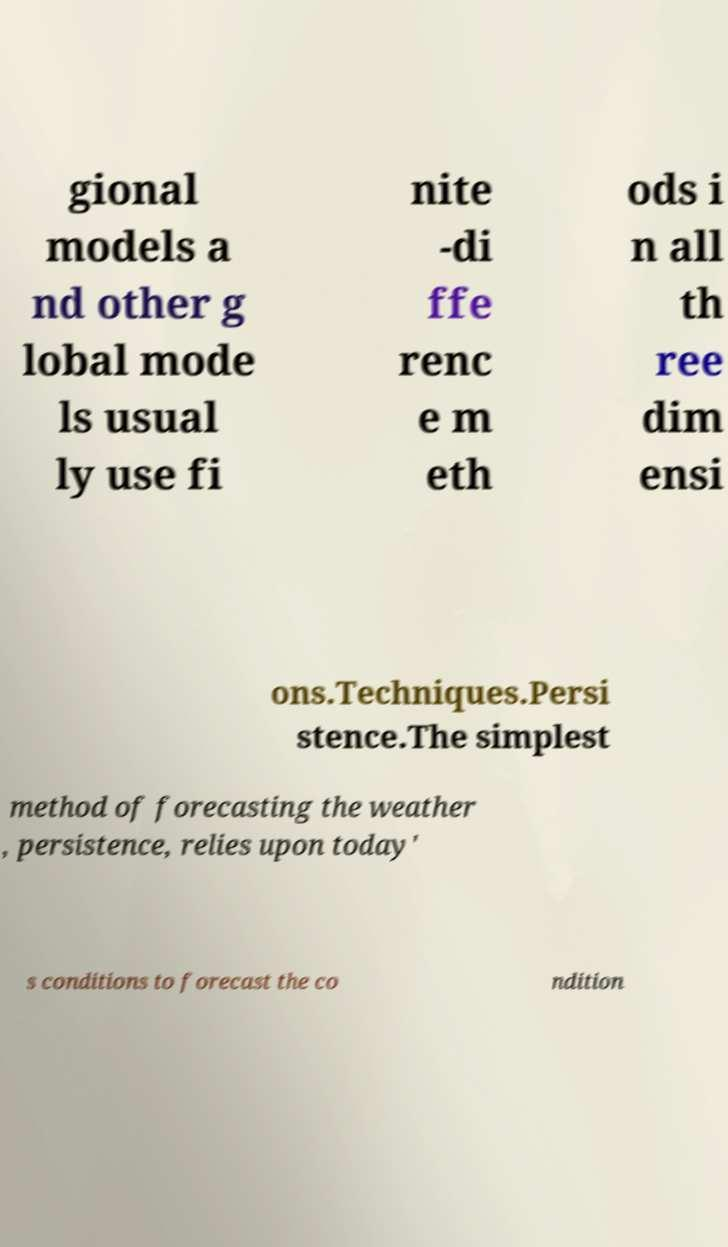Could you assist in decoding the text presented in this image and type it out clearly? gional models a nd other g lobal mode ls usual ly use fi nite -di ffe renc e m eth ods i n all th ree dim ensi ons.Techniques.Persi stence.The simplest method of forecasting the weather , persistence, relies upon today' s conditions to forecast the co ndition 